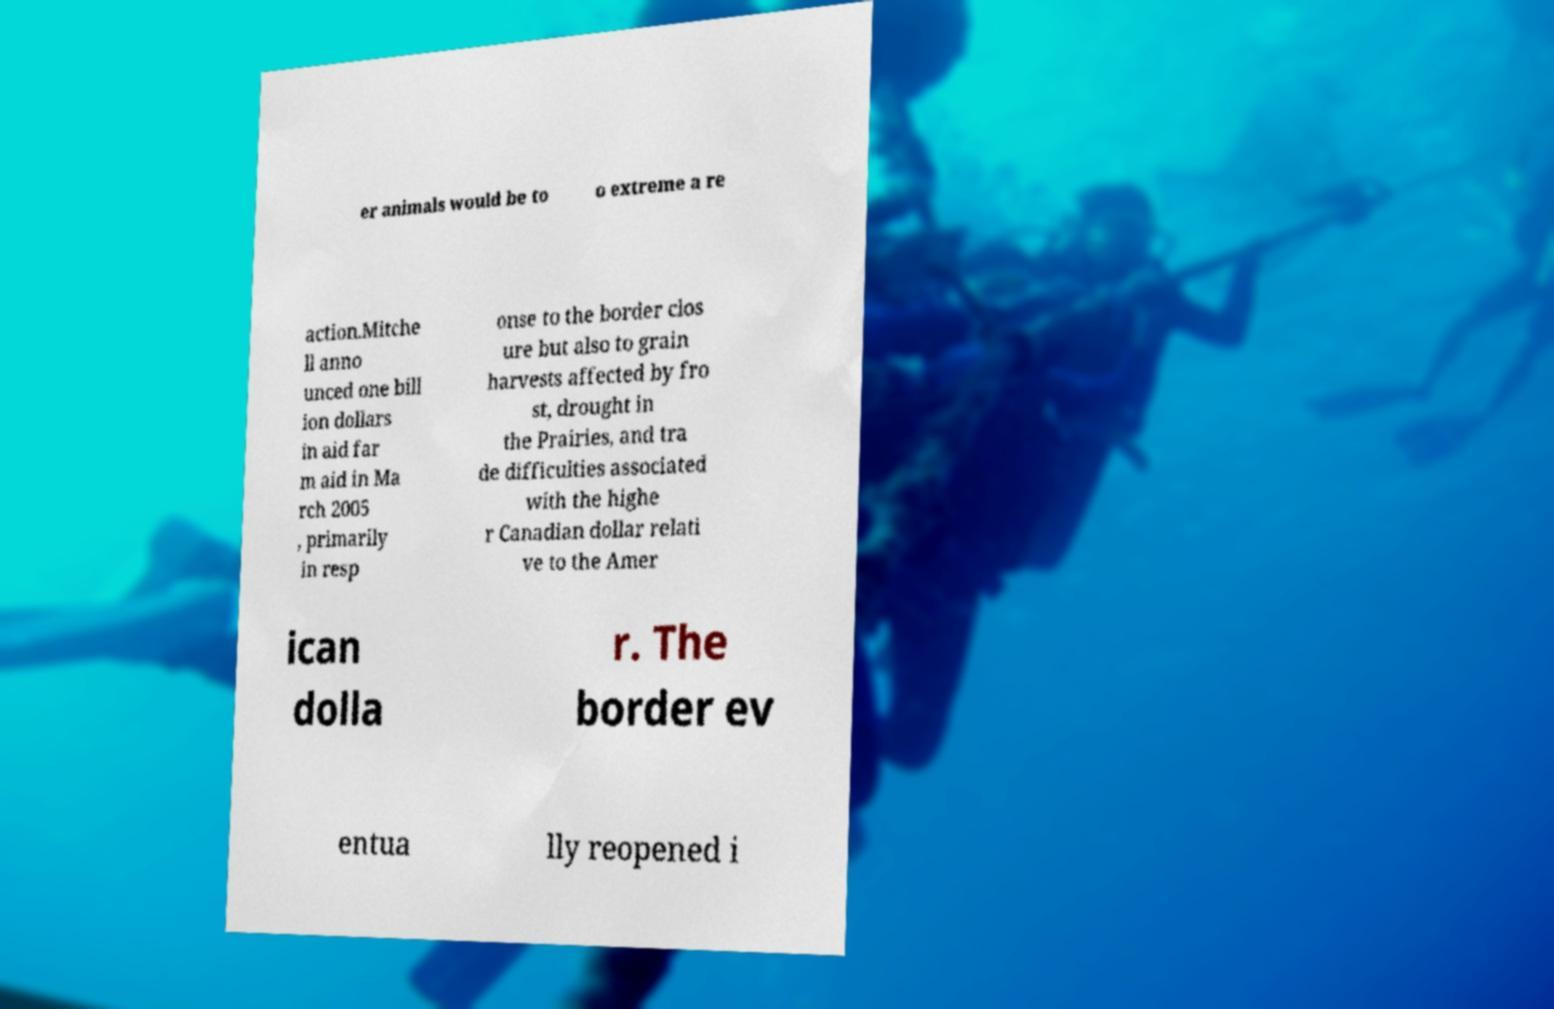There's text embedded in this image that I need extracted. Can you transcribe it verbatim? er animals would be to o extreme a re action.Mitche ll anno unced one bill ion dollars in aid far m aid in Ma rch 2005 , primarily in resp onse to the border clos ure but also to grain harvests affected by fro st, drought in the Prairies, and tra de difficulties associated with the highe r Canadian dollar relati ve to the Amer ican dolla r. The border ev entua lly reopened i 